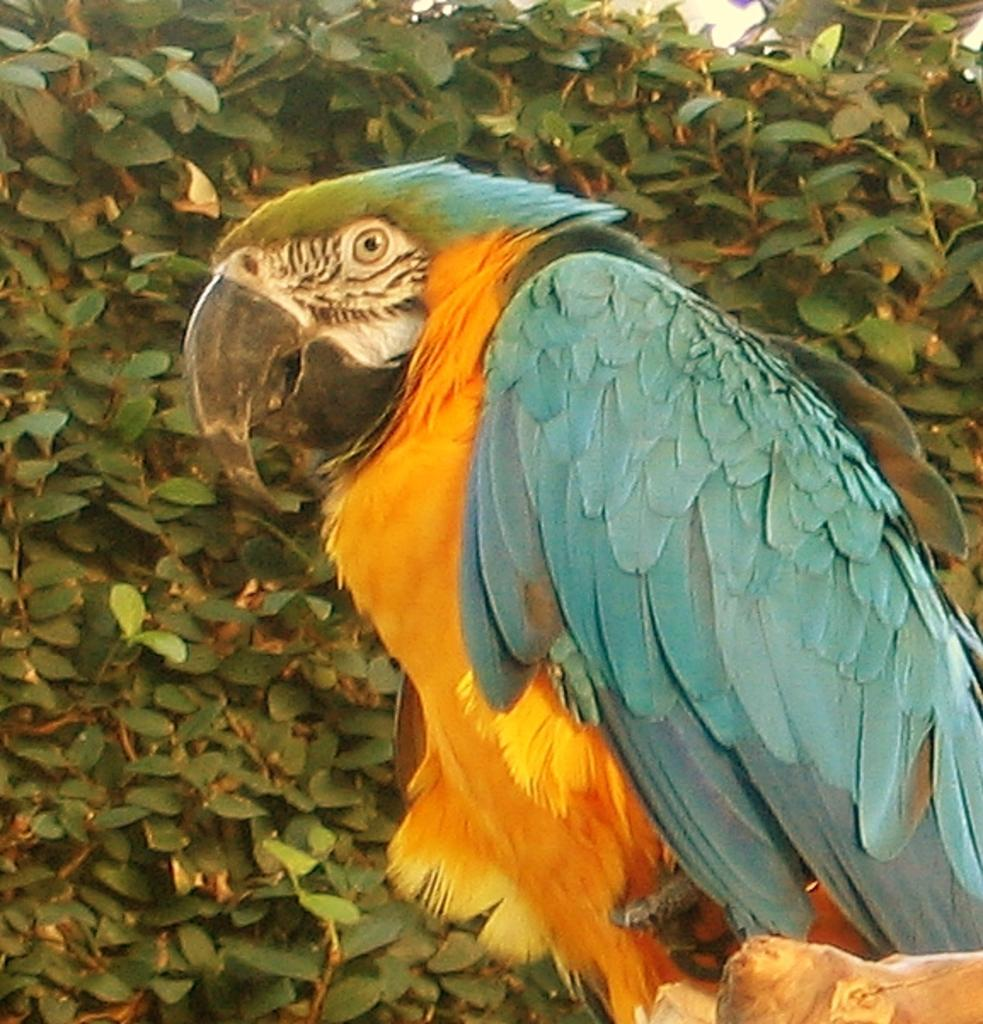What is the main subject in the foreground of the picture? There is a parrot in the foreground of the picture. Where is the parrot sitting? The parrot is sitting on the stem of a tree. What can be seen in the background of the picture? There are leaves and stems in the background of the picture. How long does it take for the parrot to fly away in the picture? The picture is a still image, so the parrot's actions are not depicted as occurring over time. Therefore, it is not possible to determine how long it takes for the parrot to fly away in the picture. 